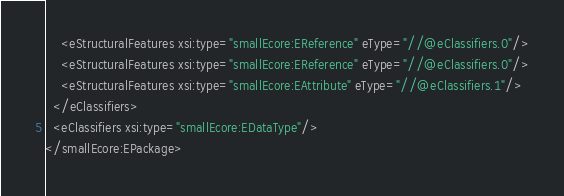Convert code to text. <code><loc_0><loc_0><loc_500><loc_500><_XML_>    <eStructuralFeatures xsi:type="smallEcore:EReference" eType="//@eClassifiers.0"/>
    <eStructuralFeatures xsi:type="smallEcore:EReference" eType="//@eClassifiers.0"/>
    <eStructuralFeatures xsi:type="smallEcore:EAttribute" eType="//@eClassifiers.1"/>
  </eClassifiers>
  <eClassifiers xsi:type="smallEcore:EDataType"/>
</smallEcore:EPackage>
</code> 